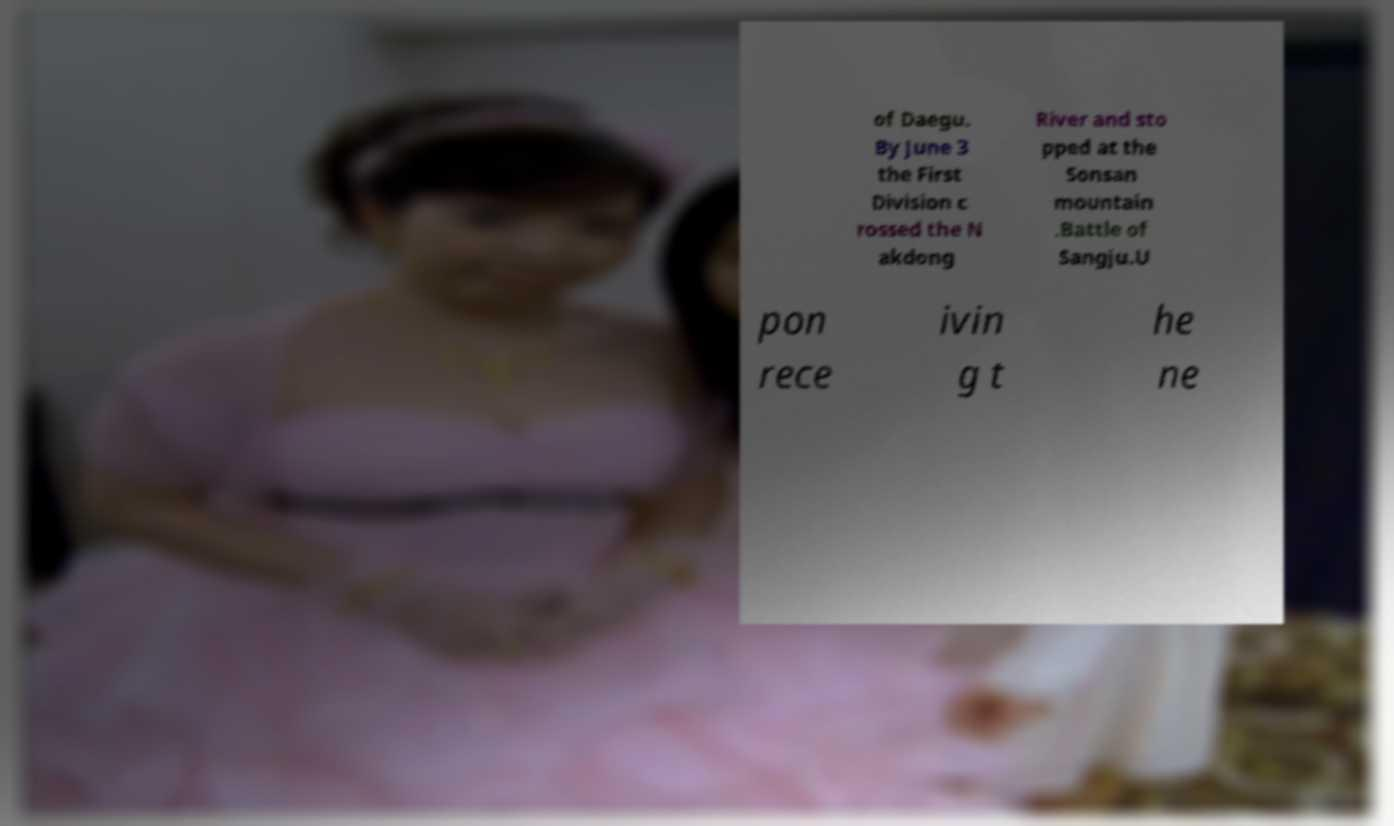I need the written content from this picture converted into text. Can you do that? of Daegu. By June 3 the First Division c rossed the N akdong River and sto pped at the Sonsan mountain .Battle of Sangju.U pon rece ivin g t he ne 